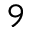<formula> <loc_0><loc_0><loc_500><loc_500>9</formula> 